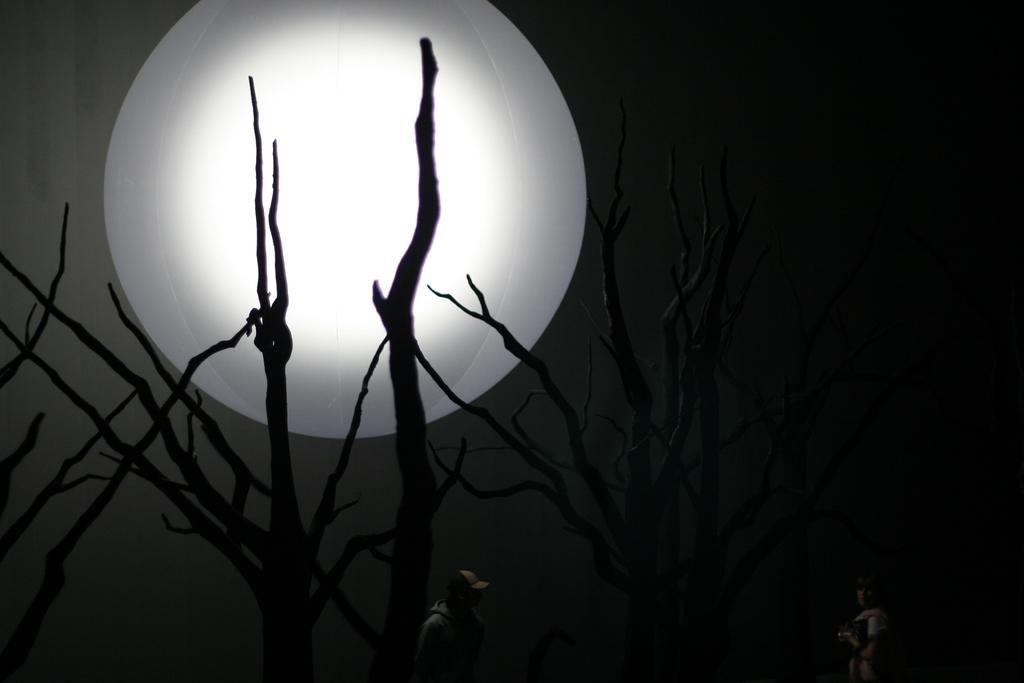What type of natural elements can be seen in the image? There are branches in the image. What celestial object is visible in the sky? There appears to be an artificial moon in the sky. How many people are present in the image? There are two people standing at the bottom of the image. What type of jam is being sold by the beggar in the image? There is no beggar or jam present in the image. What type of legal advice is the lawyer providing to the people in the image? There is no lawyer or legal advice present in the image. 